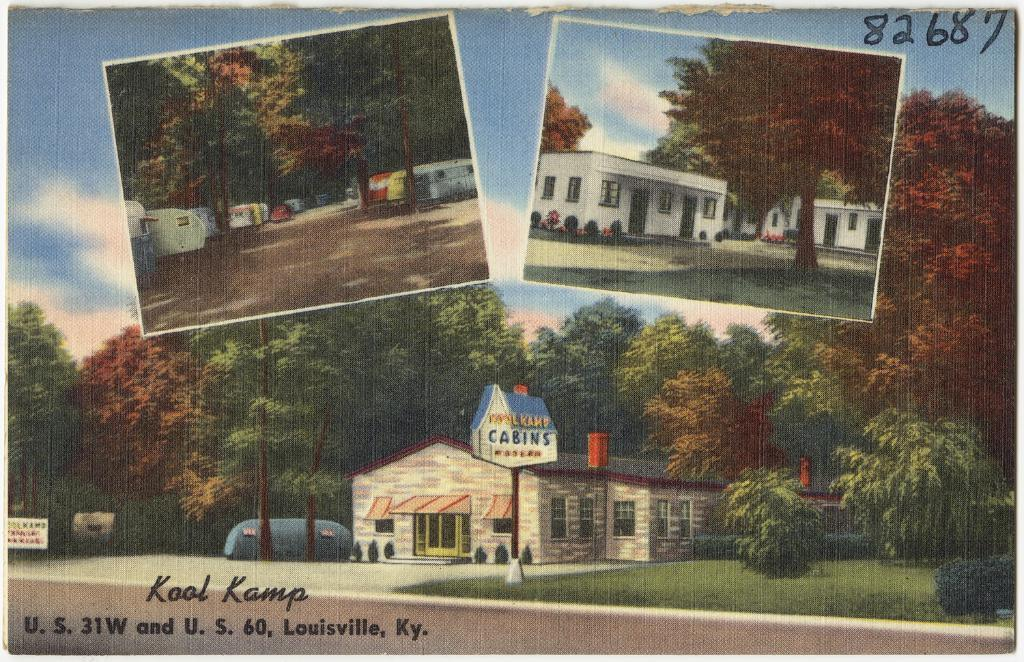What type of editing has been done to the image? The image is edited, but the specific type of editing is not mentioned in the facts. What can be seen in the image besides the editing? There are photos, houses, trees, plants, and the sky visible in the image. Can you describe the sky in the image? The sky is visible in the image, and clouds are present in the sky. What is written or displayed in the bottom left of the image? There is some text in the bottom left of the image. What type of health issues are the dinosaurs experiencing in the image? There are no dinosaurs present in the image, so it is not possible to determine any health issues they might be experiencing. 